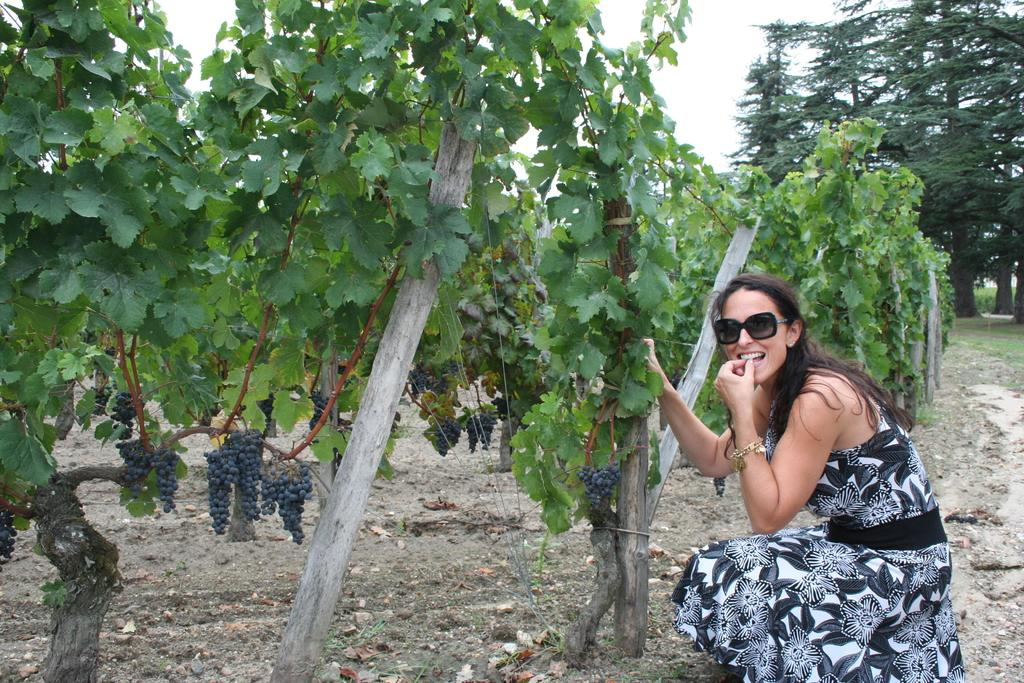Who is the main subject in the image? There is a woman in the image. What position is the woman in? The woman is sitting in a squat position. What accessory is the woman wearing? The woman is wearing glasses. What type of vegetation can be seen in the image? There are trees visible in the image. What type of fruit is present in the image? There are grapes in the image. What part of the natural environment is visible in the image? The sky is visible in the image. What type of punishment is being administered to the grapes in the image? There is no punishment being administered to the grapes in the image; they are simply present as fruit. What type of stem is visible in the image? There is no stem visible in the image. 